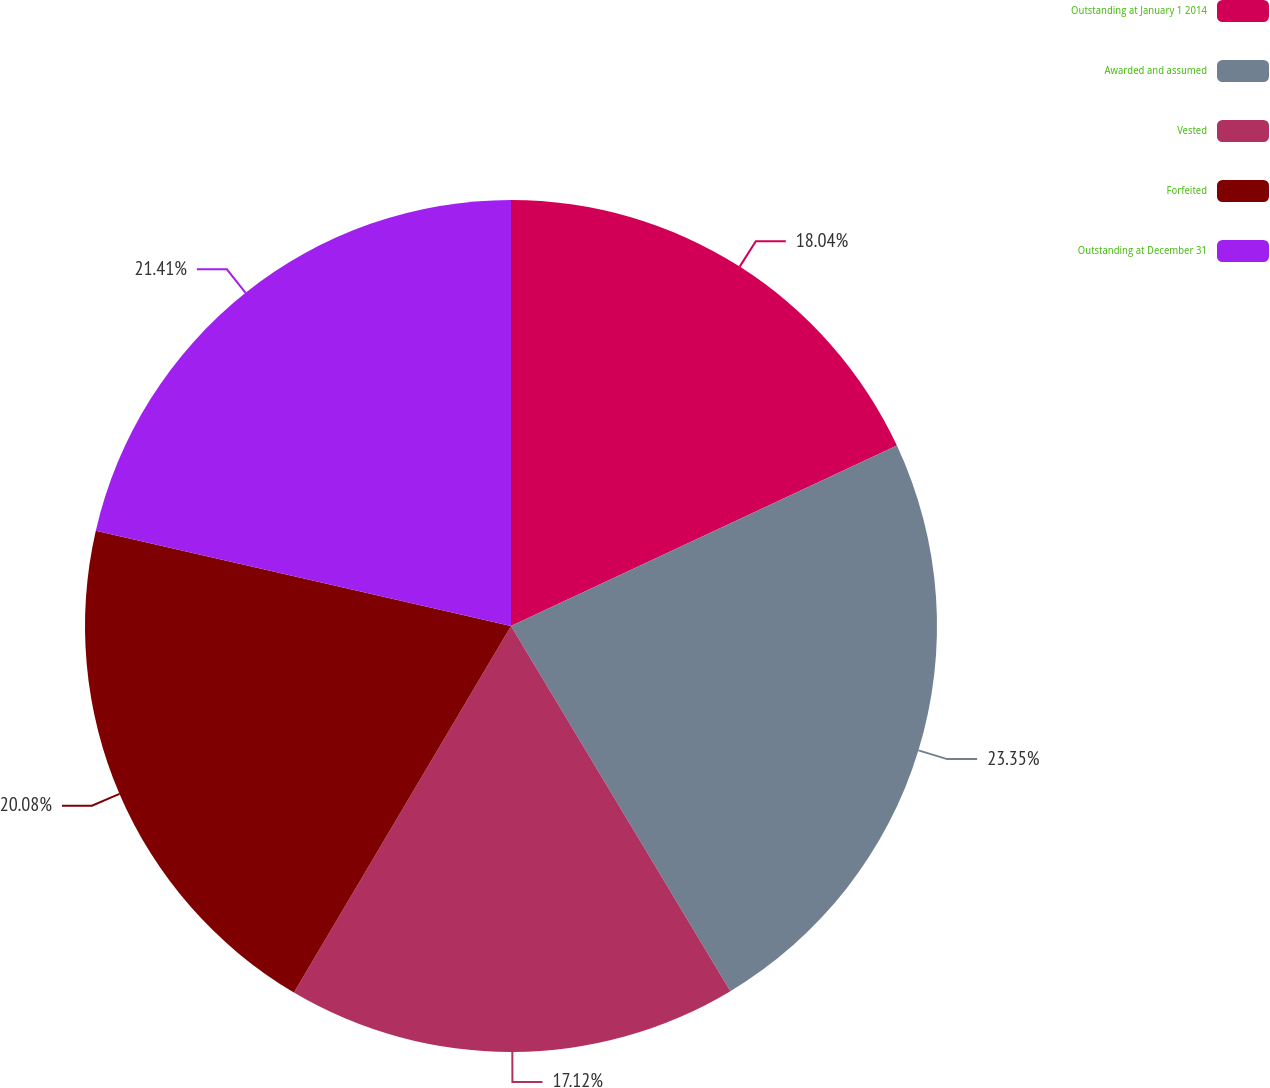Convert chart to OTSL. <chart><loc_0><loc_0><loc_500><loc_500><pie_chart><fcel>Outstanding at January 1 2014<fcel>Awarded and assumed<fcel>Vested<fcel>Forfeited<fcel>Outstanding at December 31<nl><fcel>18.04%<fcel>23.35%<fcel>17.12%<fcel>20.08%<fcel>21.41%<nl></chart> 